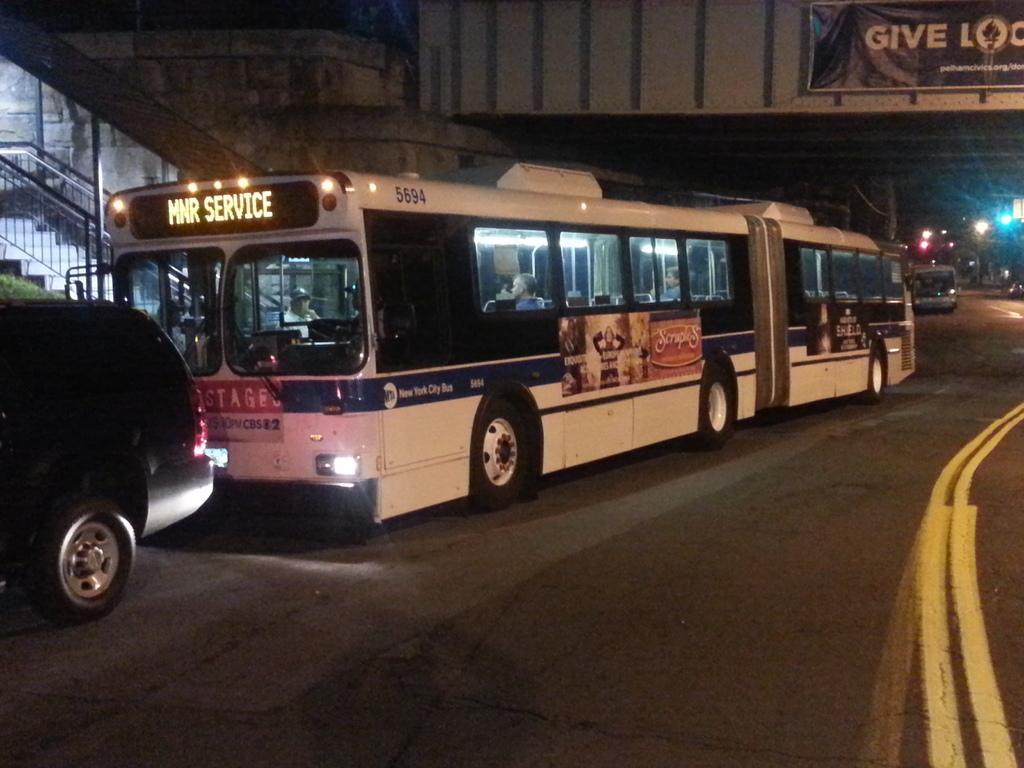Please provide a concise description of this image. In this picture we can see a few vehicles on the road. There are plants, stairs, staircase holders, lights, some text and a few things on the board. We can see other objects. 